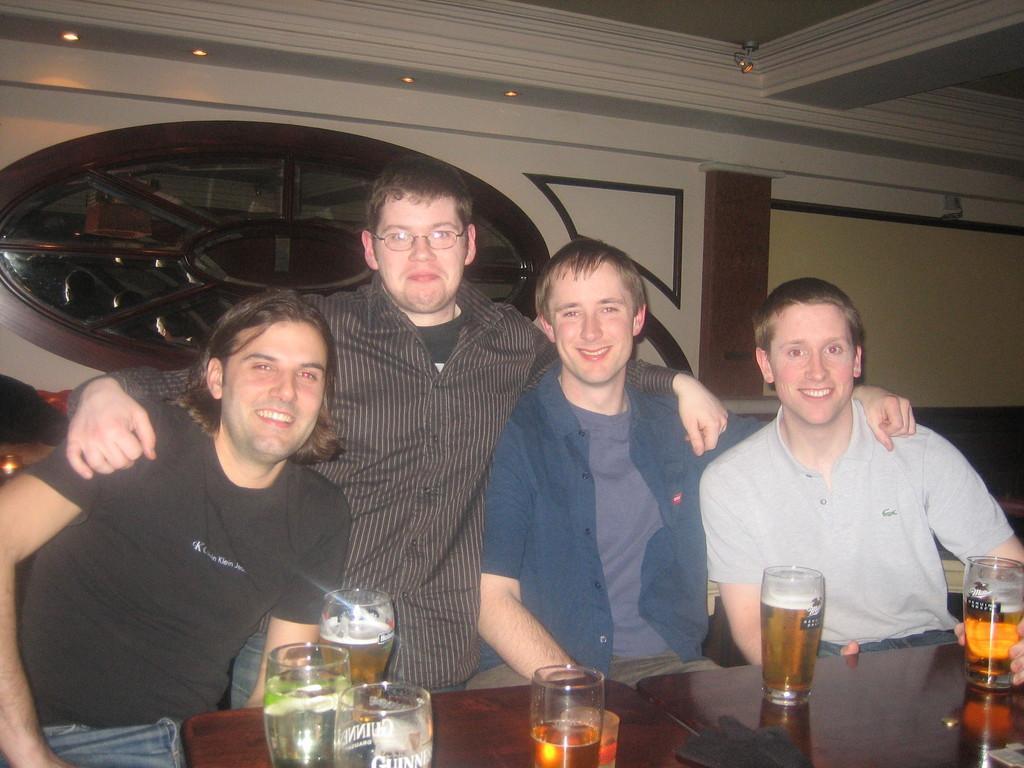Could you give a brief overview of what you see in this image? In this image I can see group of people. In front the person is wearing black color shirt and I can also see few glasses on the table, background I can see few lights and the wall is in white, brown and cream color. 